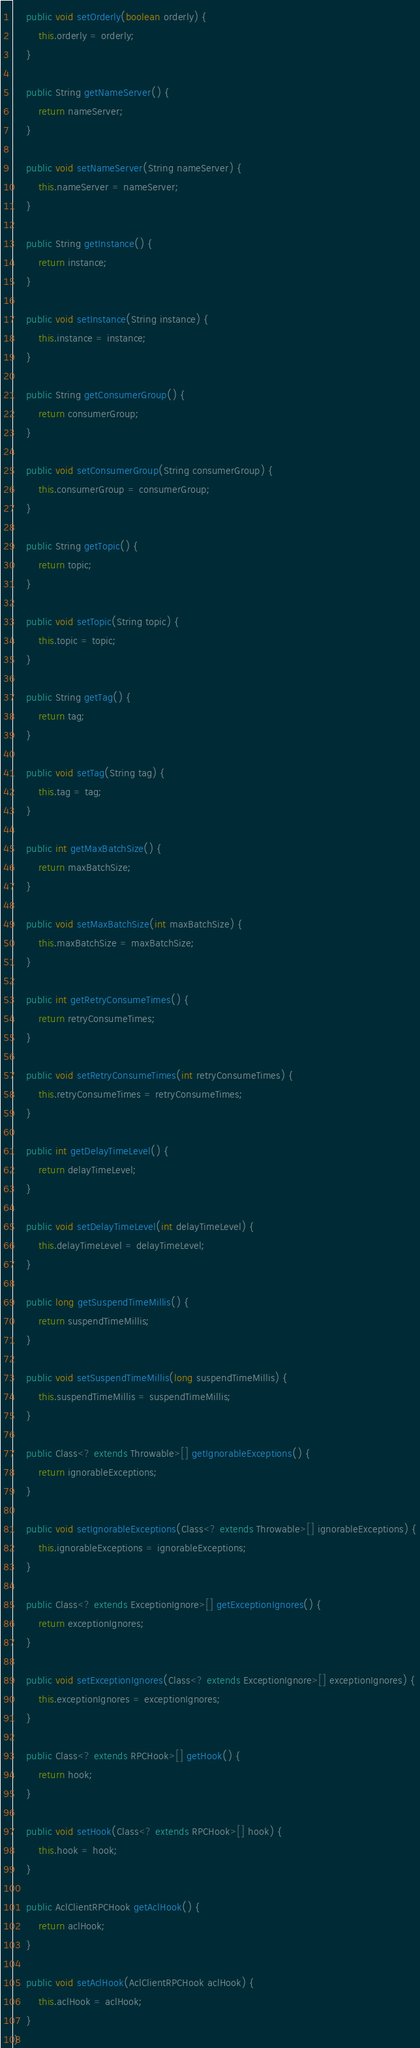Convert code to text. <code><loc_0><loc_0><loc_500><loc_500><_Java_>
    public void setOrderly(boolean orderly) {
        this.orderly = orderly;
    }

    public String getNameServer() {
        return nameServer;
    }

    public void setNameServer(String nameServer) {
        this.nameServer = nameServer;
    }

    public String getInstance() {
        return instance;
    }

    public void setInstance(String instance) {
        this.instance = instance;
    }

    public String getConsumerGroup() {
        return consumerGroup;
    }

    public void setConsumerGroup(String consumerGroup) {
        this.consumerGroup = consumerGroup;
    }

    public String getTopic() {
        return topic;
    }

    public void setTopic(String topic) {
        this.topic = topic;
    }

    public String getTag() {
        return tag;
    }

    public void setTag(String tag) {
        this.tag = tag;
    }

    public int getMaxBatchSize() {
        return maxBatchSize;
    }

    public void setMaxBatchSize(int maxBatchSize) {
        this.maxBatchSize = maxBatchSize;
    }

    public int getRetryConsumeTimes() {
        return retryConsumeTimes;
    }

    public void setRetryConsumeTimes(int retryConsumeTimes) {
        this.retryConsumeTimes = retryConsumeTimes;
    }

    public int getDelayTimeLevel() {
        return delayTimeLevel;
    }

    public void setDelayTimeLevel(int delayTimeLevel) {
        this.delayTimeLevel = delayTimeLevel;
    }

    public long getSuspendTimeMillis() {
        return suspendTimeMillis;
    }

    public void setSuspendTimeMillis(long suspendTimeMillis) {
        this.suspendTimeMillis = suspendTimeMillis;
    }

    public Class<? extends Throwable>[] getIgnorableExceptions() {
        return ignorableExceptions;
    }

    public void setIgnorableExceptions(Class<? extends Throwable>[] ignorableExceptions) {
        this.ignorableExceptions = ignorableExceptions;
    }

    public Class<? extends ExceptionIgnore>[] getExceptionIgnores() {
        return exceptionIgnores;
    }

    public void setExceptionIgnores(Class<? extends ExceptionIgnore>[] exceptionIgnores) {
        this.exceptionIgnores = exceptionIgnores;
    }

    public Class<? extends RPCHook>[] getHook() {
        return hook;
    }

    public void setHook(Class<? extends RPCHook>[] hook) {
        this.hook = hook;
    }

    public AclClientRPCHook getAclHook() {
        return aclHook;
    }

    public void setAclHook(AclClientRPCHook aclHook) {
        this.aclHook = aclHook;
    }
}
</code> 